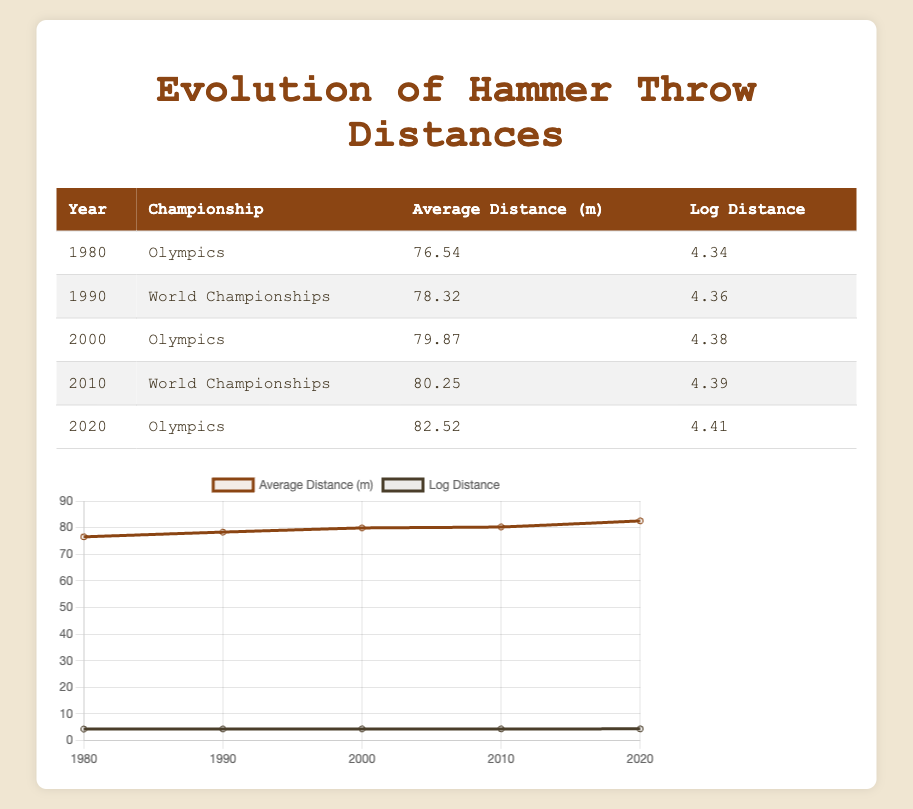What was the average hammer throw distance in the 2000 Olympics? According to the table, the average distance for the 2000 Olympics is listed as 79.87 meters.
Answer: 79.87 meters Which championship in 2010 had a higher average throw distance, the World Championships or the Olympics? The table indicates that in 2010, the average distance for the World Championships was 80.25 meters, while there is no Olympics listed for that year. Therefore, the World Championships had a higher average throw distance.
Answer: World Championships What is the difference in average hammer throw distance between the years 1980 and 2020? In 1980, the average distance was 76.54 meters, and in 2020 it was 82.52 meters. The difference is calculated by subtracting 76.54 from 82.52, which equals 5.98 meters.
Answer: 5.98 meters Was there an increase in average distance from 1990 to 2000? The average distance in 1990 was 78.32 meters and in 2000 it was 79.87 meters. Since 79.87 is greater than 78.32, there was indeed an increase.
Answer: Yes What is the average of the average distances from all the years listed? To find the average of the average distances, sum the distances: 76.54 + 78.32 + 79.87 + 80.25 + 82.52 = 397.50 meters. Then, divide by the number of entries, which is 5. So, 397.50 / 5 = 79.50 meters.
Answer: 79.50 meters How much did the average distance from the Olympics in 1980 compare to the average distance in the Olympics 2020? The average in 1980 was 76.54 meters and in 2020 it was 82.52 meters. The comparison shows a significant increase from 76.54 to 82.52 meters, which is a difference of 5.98 meters.
Answer: Increased by 5.98 meters What is the log distance for the average distance recorded in the 2010 World Championships? The table shows that the log distance for the 2010 World Championships is 4.39, which directly corresponds to the average distance recorded.
Answer: 4.39 In which year was the smallest average hammer throw distance recorded? Referring to the table, the smallest average distance is 76.54 meters, recorded in 1980 during the Olympics.
Answer: 1980 Did the average distance ever decrease over the years listed in the table? By examining the values in the table, the average distances consistently increased from 1980 to 2020, with no instances of a decrease.
Answer: No 